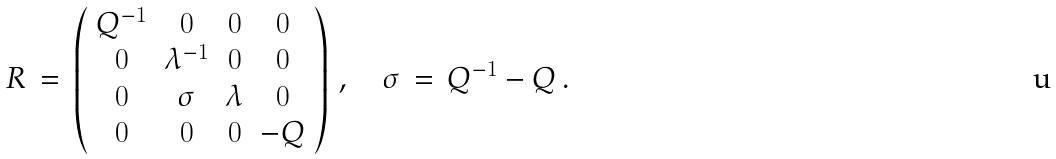<formula> <loc_0><loc_0><loc_500><loc_500>R \, = \, \left ( \begin{array} { c c c c } { { Q ^ { - 1 } } } & { 0 } & { 0 } & { 0 } \\ { 0 } & { { \lambda ^ { - 1 } } } & { 0 } & { 0 } \\ { 0 } & { \sigma } & { \lambda } & { 0 } \\ { 0 } & { 0 } & { 0 } & { - Q } \end{array} \right ) \, , \quad \sigma \, = \, Q ^ { - 1 } - Q \, .</formula> 